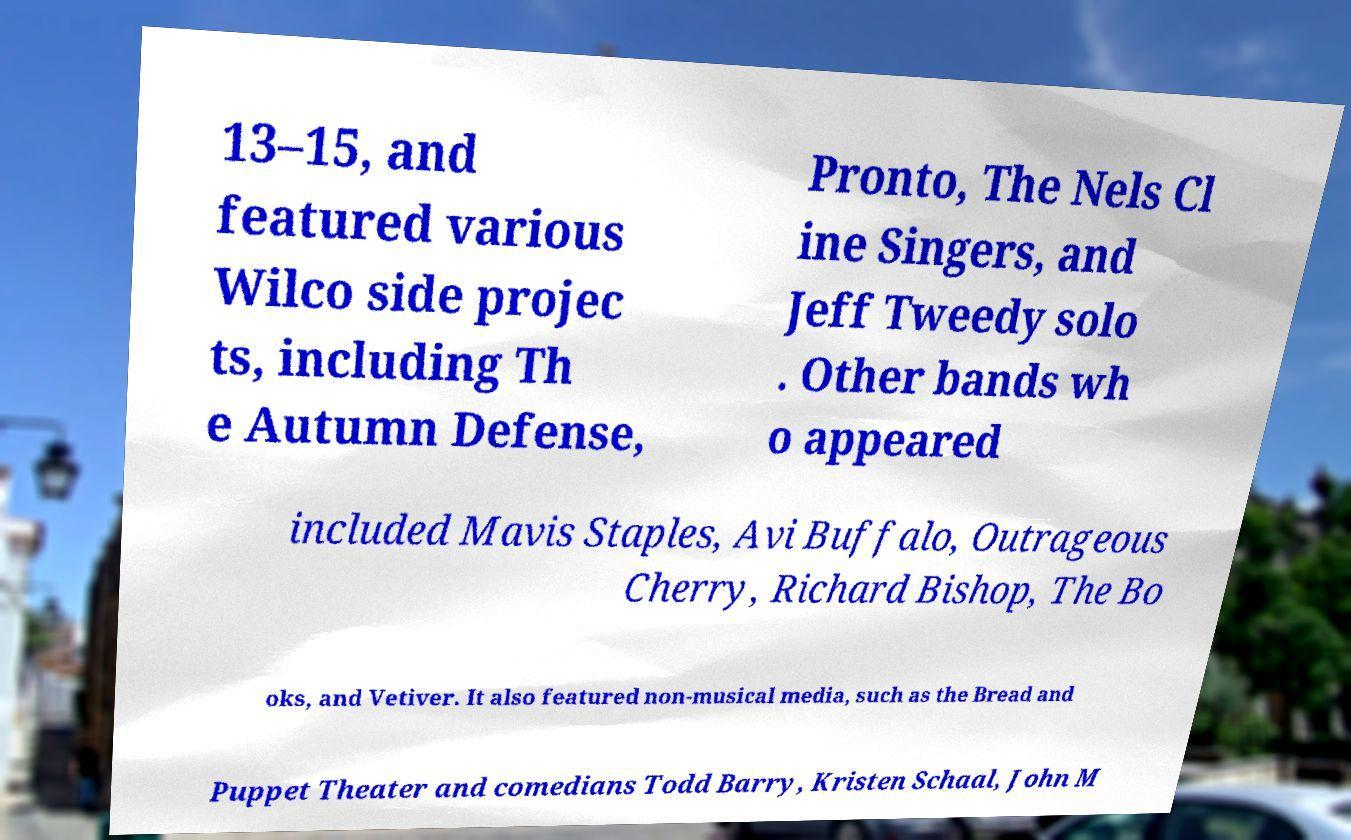I need the written content from this picture converted into text. Can you do that? 13–15, and featured various Wilco side projec ts, including Th e Autumn Defense, Pronto, The Nels Cl ine Singers, and Jeff Tweedy solo . Other bands wh o appeared included Mavis Staples, Avi Buffalo, Outrageous Cherry, Richard Bishop, The Bo oks, and Vetiver. It also featured non-musical media, such as the Bread and Puppet Theater and comedians Todd Barry, Kristen Schaal, John M 